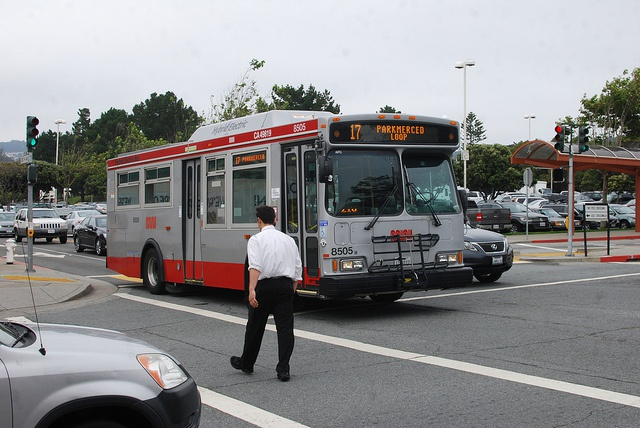Describe the objects in this image and their specific colors. I can see bus in white, black, gray, darkgray, and brown tones, car in white, lightgray, black, darkgray, and gray tones, people in white, black, lightgray, darkgray, and salmon tones, car in white, black, gray, and darkgray tones, and car in white, black, gray, and darkgray tones in this image. 